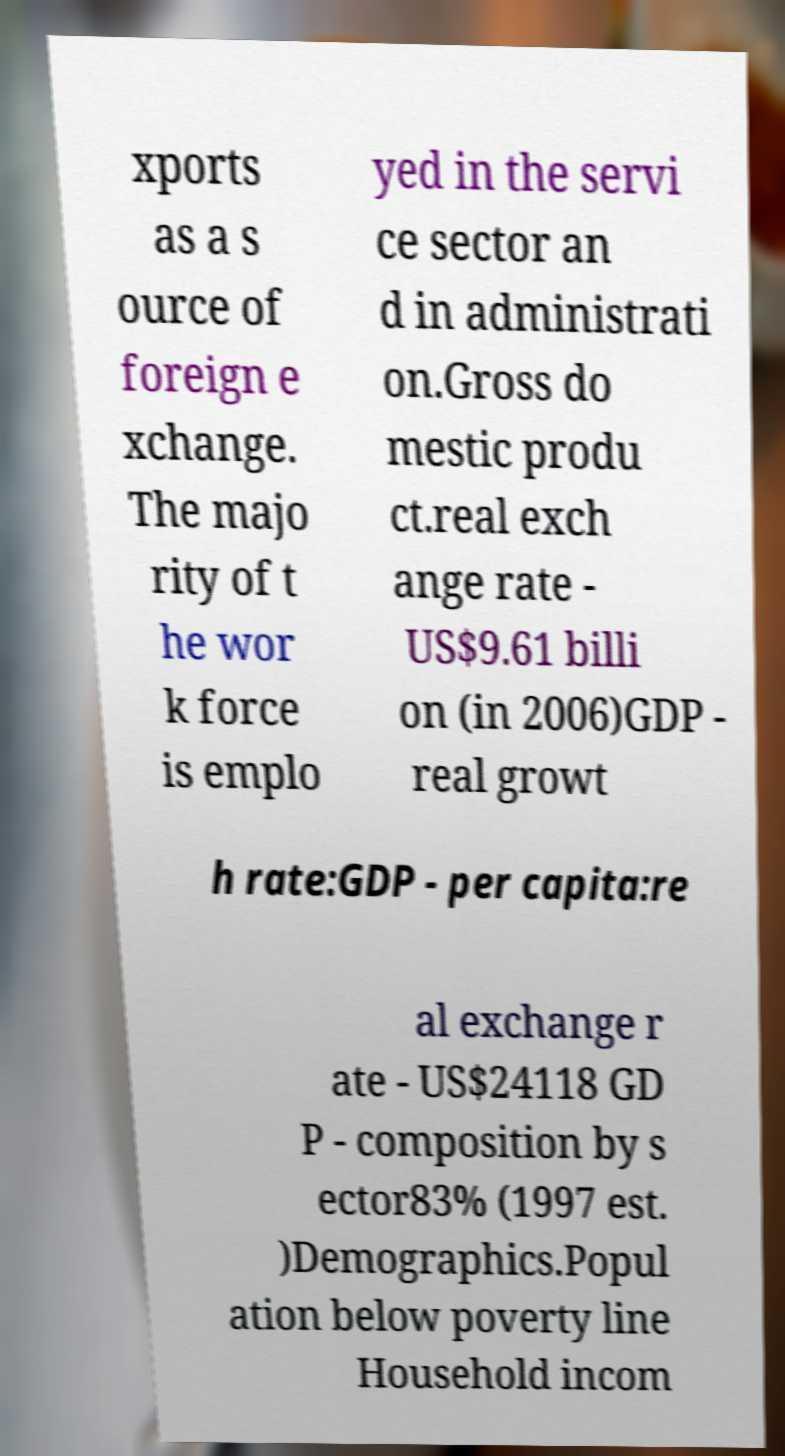For documentation purposes, I need the text within this image transcribed. Could you provide that? xports as a s ource of foreign e xchange. The majo rity of t he wor k force is emplo yed in the servi ce sector an d in administrati on.Gross do mestic produ ct.real exch ange rate - US$9.61 billi on (in 2006)GDP - real growt h rate:GDP - per capita:re al exchange r ate - US$24118 GD P - composition by s ector83% (1997 est. )Demographics.Popul ation below poverty line Household incom 